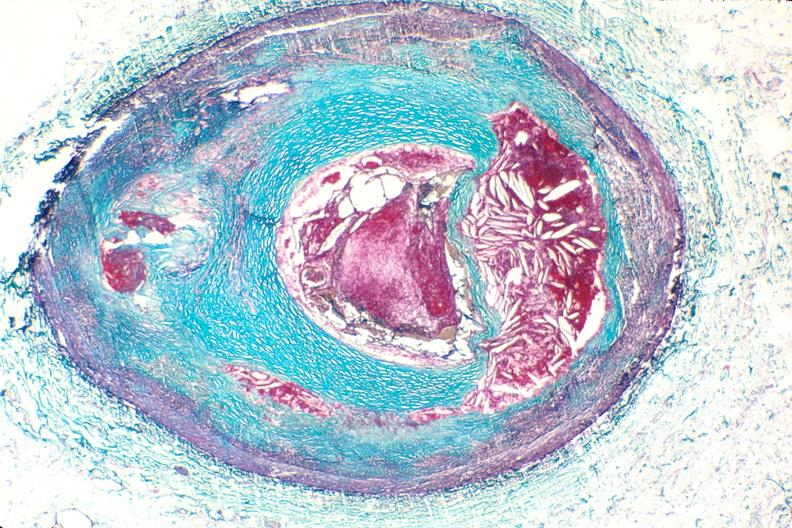what is present?
Answer the question using a single word or phrase. Cardiovascular 